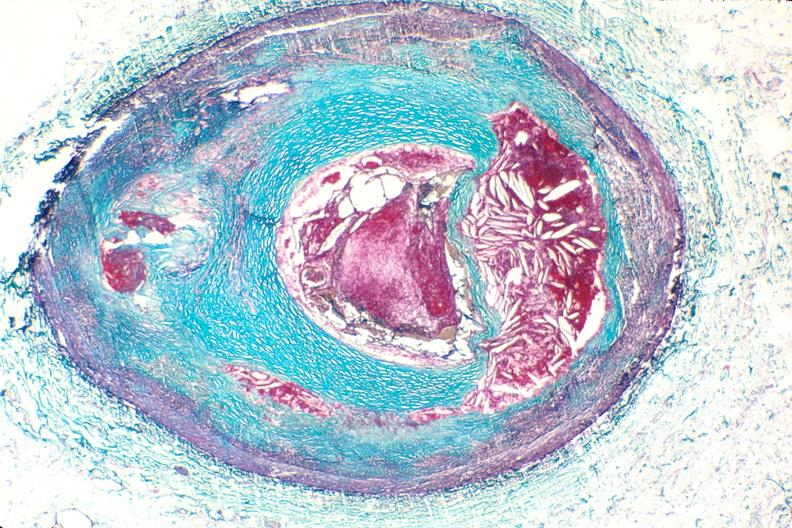what is present?
Answer the question using a single word or phrase. Cardiovascular 